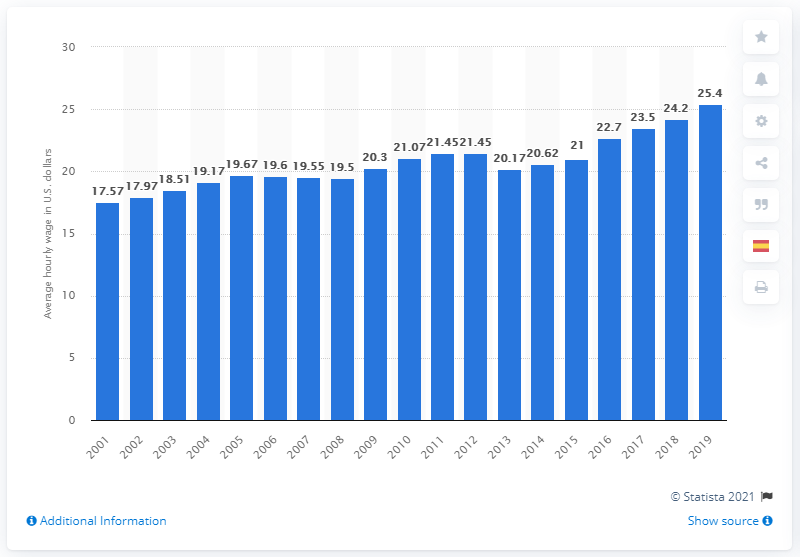Give some essential details in this illustration. In 2019, the average hourly wage for a chemical production worker was $25.40. 